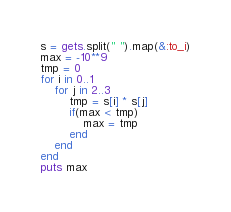Convert code to text. <code><loc_0><loc_0><loc_500><loc_500><_Ruby_>s = gets.split(" ").map(&:to_i)
max = -10**9
tmp = 0
for i in 0..1
	for j in 2..3
		tmp = s[i] * s[j]
		if(max < tmp)
			max = tmp
		end
	end
end
puts max</code> 